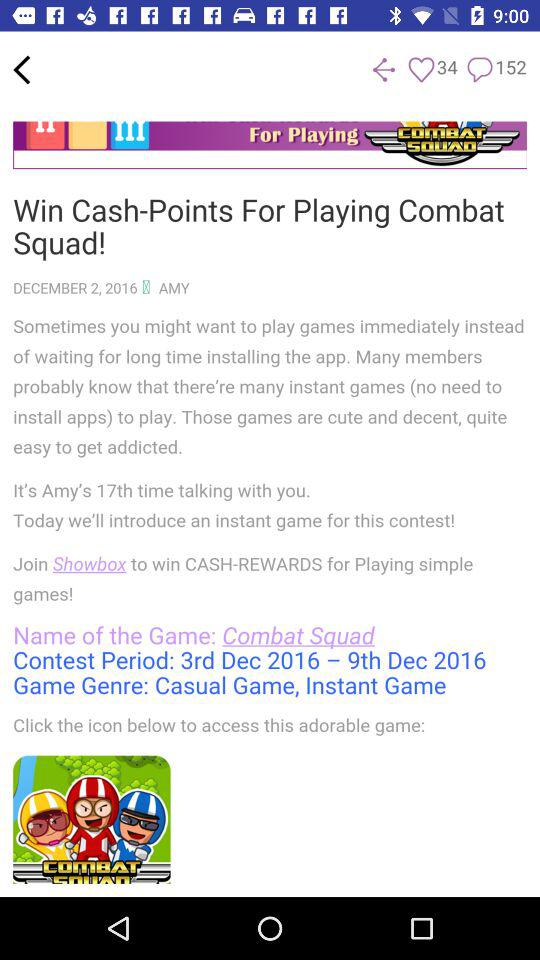On which date was the article published? The article was published on December 2, 2016. 